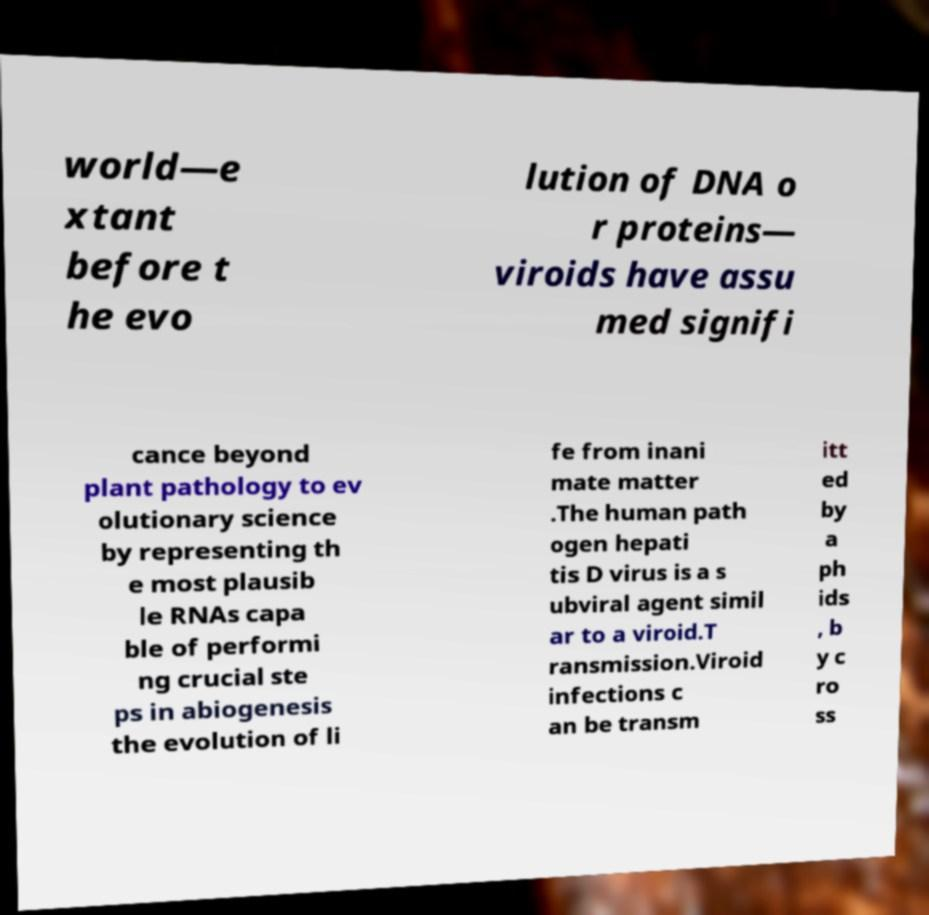Please read and relay the text visible in this image. What does it say? world—e xtant before t he evo lution of DNA o r proteins— viroids have assu med signifi cance beyond plant pathology to ev olutionary science by representing th e most plausib le RNAs capa ble of performi ng crucial ste ps in abiogenesis the evolution of li fe from inani mate matter .The human path ogen hepati tis D virus is a s ubviral agent simil ar to a viroid.T ransmission.Viroid infections c an be transm itt ed by a ph ids , b y c ro ss 